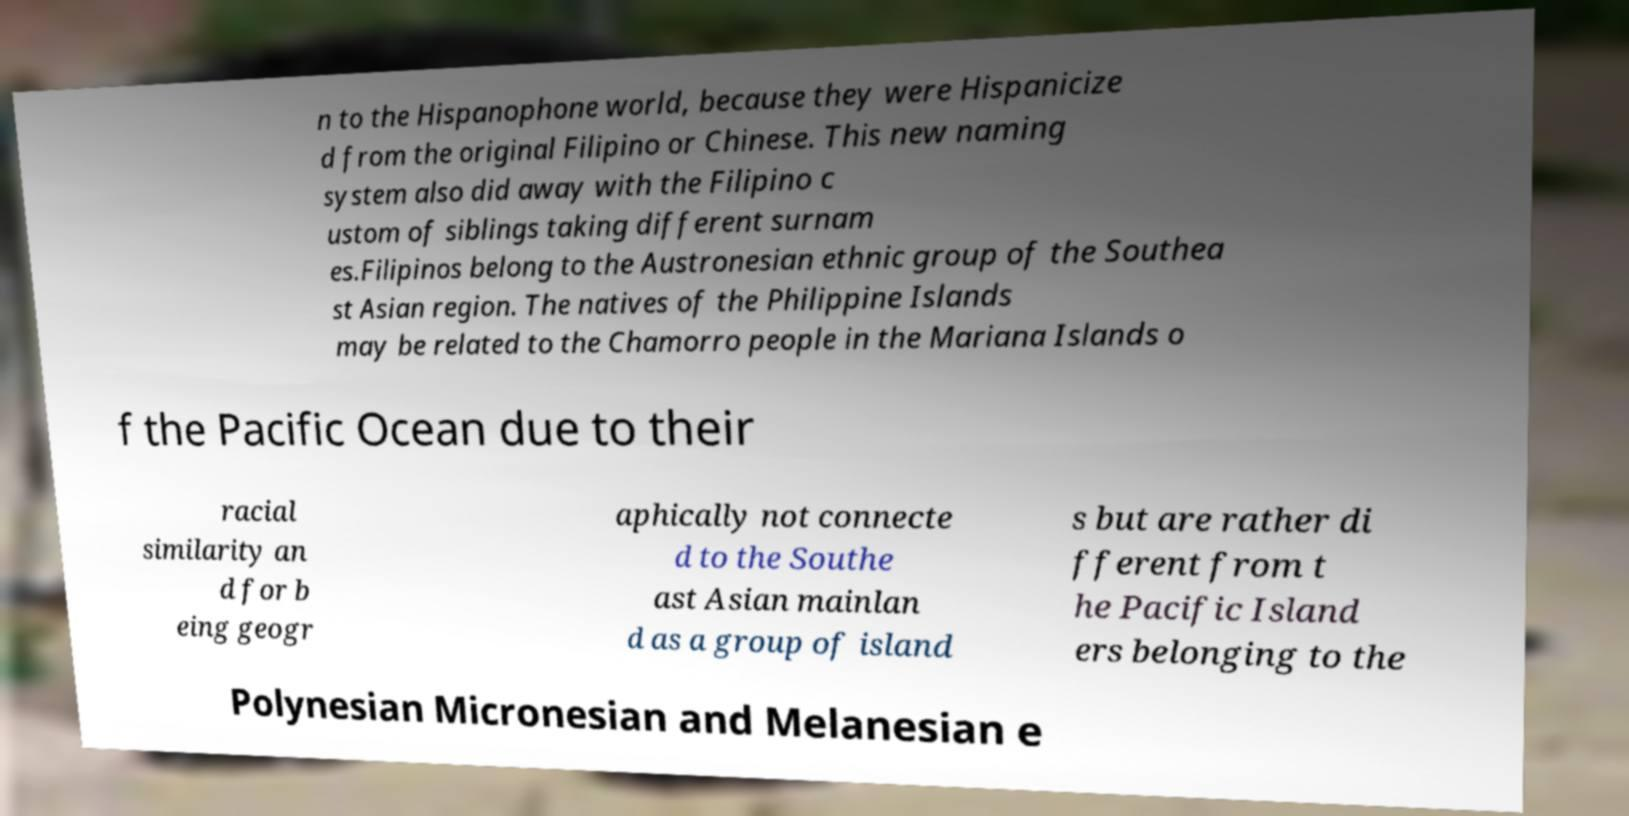I need the written content from this picture converted into text. Can you do that? n to the Hispanophone world, because they were Hispanicize d from the original Filipino or Chinese. This new naming system also did away with the Filipino c ustom of siblings taking different surnam es.Filipinos belong to the Austronesian ethnic group of the Southea st Asian region. The natives of the Philippine Islands may be related to the Chamorro people in the Mariana Islands o f the Pacific Ocean due to their racial similarity an d for b eing geogr aphically not connecte d to the Southe ast Asian mainlan d as a group of island s but are rather di fferent from t he Pacific Island ers belonging to the Polynesian Micronesian and Melanesian e 